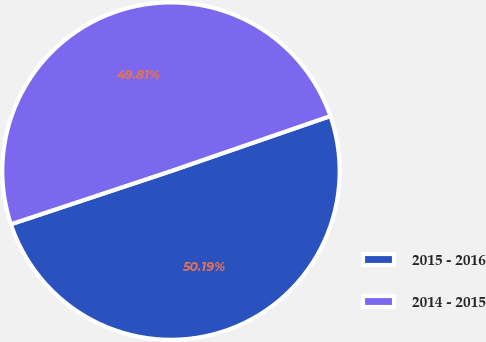Convert chart. <chart><loc_0><loc_0><loc_500><loc_500><pie_chart><fcel>2015 - 2016<fcel>2014 - 2015<nl><fcel>50.19%<fcel>49.81%<nl></chart> 